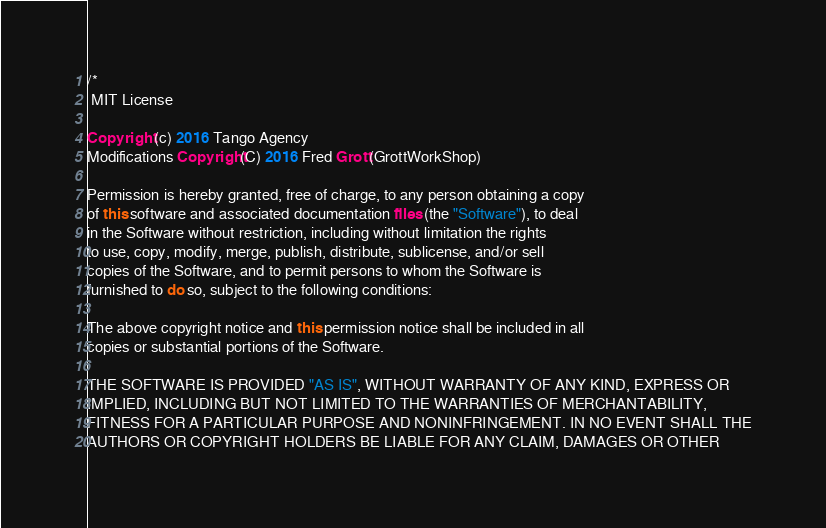Convert code to text. <code><loc_0><loc_0><loc_500><loc_500><_Java_>/*
 MIT License

Copyright (c) 2016 Tango Agency
Modifications Copyright(C) 2016 Fred Grott(GrottWorkShop)

Permission is hereby granted, free of charge, to any person obtaining a copy
of this software and associated documentation files (the "Software"), to deal
in the Software without restriction, including without limitation the rights
to use, copy, modify, merge, publish, distribute, sublicense, and/or sell
copies of the Software, and to permit persons to whom the Software is
furnished to do so, subject to the following conditions:

The above copyright notice and this permission notice shall be included in all
copies or substantial portions of the Software.

THE SOFTWARE IS PROVIDED "AS IS", WITHOUT WARRANTY OF ANY KIND, EXPRESS OR
IMPLIED, INCLUDING BUT NOT LIMITED TO THE WARRANTIES OF MERCHANTABILITY,
FITNESS FOR A PARTICULAR PURPOSE AND NONINFRINGEMENT. IN NO EVENT SHALL THE
AUTHORS OR COPYRIGHT HOLDERS BE LIABLE FOR ANY CLAIM, DAMAGES OR OTHER</code> 